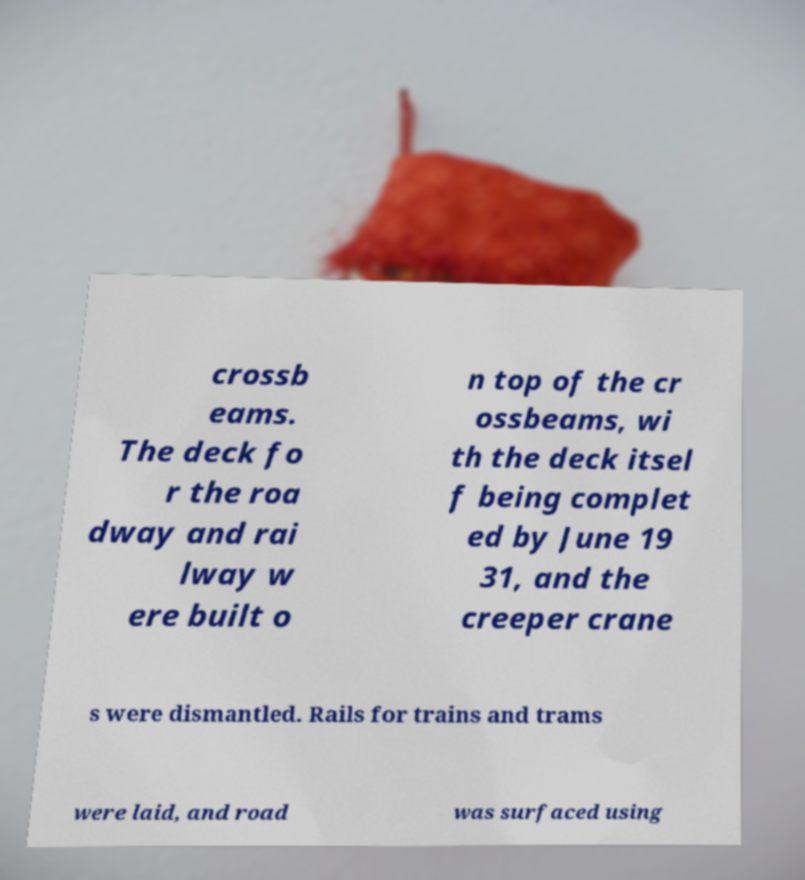Please identify and transcribe the text found in this image. crossb eams. The deck fo r the roa dway and rai lway w ere built o n top of the cr ossbeams, wi th the deck itsel f being complet ed by June 19 31, and the creeper crane s were dismantled. Rails for trains and trams were laid, and road was surfaced using 